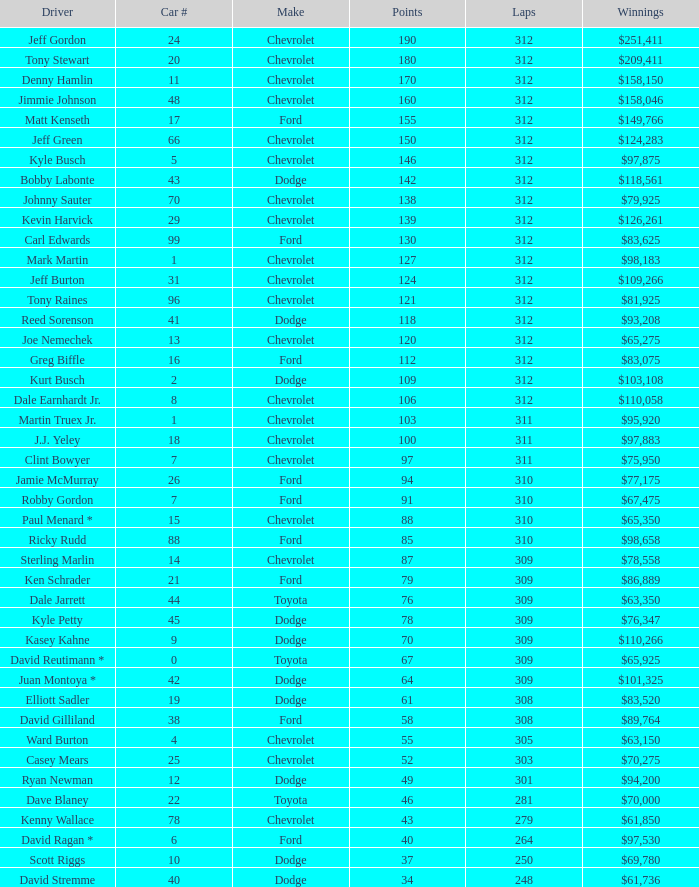For a car with a number above 1, being a ford, and possessing 155 points, what is the combined number of laps? 312.0. 